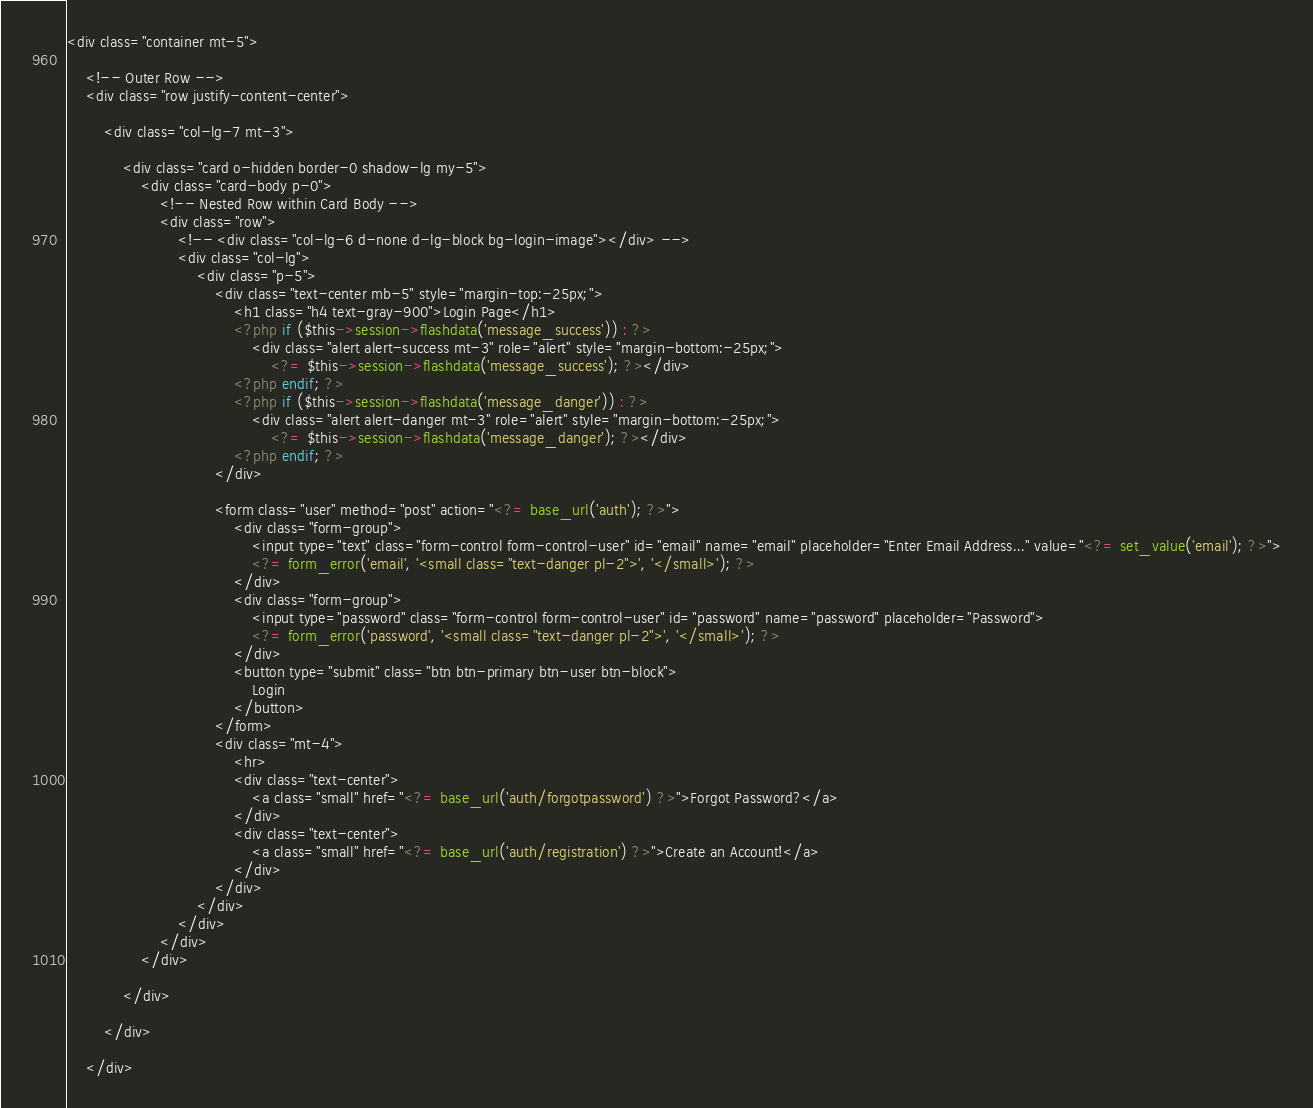<code> <loc_0><loc_0><loc_500><loc_500><_PHP_><div class="container mt-5">

    <!-- Outer Row -->
    <div class="row justify-content-center">

        <div class="col-lg-7 mt-3">

            <div class="card o-hidden border-0 shadow-lg my-5">
                <div class="card-body p-0">
                    <!-- Nested Row within Card Body -->
                    <div class="row">
                        <!-- <div class="col-lg-6 d-none d-lg-block bg-login-image"></div> -->
                        <div class="col-lg">
                            <div class="p-5">
                                <div class="text-center mb-5" style="margin-top:-25px;">
                                    <h1 class="h4 text-gray-900">Login Page</h1>
                                    <?php if ($this->session->flashdata('message_success')) : ?>
                                        <div class="alert alert-success mt-3" role="alert" style="margin-bottom:-25px;">
                                            <?= $this->session->flashdata('message_success'); ?></div>
                                    <?php endif; ?>
                                    <?php if ($this->session->flashdata('message_danger')) : ?>
                                        <div class="alert alert-danger mt-3" role="alert" style="margin-bottom:-25px;">
                                            <?= $this->session->flashdata('message_danger'); ?></div>
                                    <?php endif; ?>
                                </div>

                                <form class="user" method="post" action="<?= base_url('auth'); ?>">
                                    <div class="form-group">
                                        <input type="text" class="form-control form-control-user" id="email" name="email" placeholder="Enter Email Address..." value="<?= set_value('email'); ?>">
                                        <?= form_error('email', '<small class="text-danger pl-2">', '</small>'); ?>
                                    </div>
                                    <div class="form-group">
                                        <input type="password" class="form-control form-control-user" id="password" name="password" placeholder="Password">
                                        <?= form_error('password', '<small class="text-danger pl-2">', '</small>'); ?>
                                    </div>
                                    <button type="submit" class="btn btn-primary btn-user btn-block">
                                        Login
                                    </button>
                                </form>
                                <div class="mt-4">
                                    <hr>
                                    <div class="text-center">
                                        <a class="small" href="<?= base_url('auth/forgotpassword') ?>">Forgot Password?</a>
                                    </div>
                                    <div class="text-center">
                                        <a class="small" href="<?= base_url('auth/registration') ?>">Create an Account!</a>
                                    </div>
                                </div>
                            </div>
                        </div>
                    </div>
                </div>

            </div>

        </div>

    </div></code> 